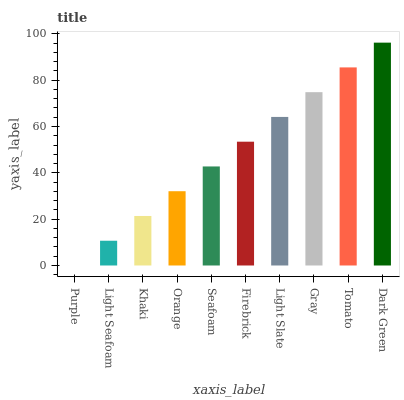Is Purple the minimum?
Answer yes or no. Yes. Is Dark Green the maximum?
Answer yes or no. Yes. Is Light Seafoam the minimum?
Answer yes or no. No. Is Light Seafoam the maximum?
Answer yes or no. No. Is Light Seafoam greater than Purple?
Answer yes or no. Yes. Is Purple less than Light Seafoam?
Answer yes or no. Yes. Is Purple greater than Light Seafoam?
Answer yes or no. No. Is Light Seafoam less than Purple?
Answer yes or no. No. Is Firebrick the high median?
Answer yes or no. Yes. Is Seafoam the low median?
Answer yes or no. Yes. Is Light Seafoam the high median?
Answer yes or no. No. Is Light Seafoam the low median?
Answer yes or no. No. 